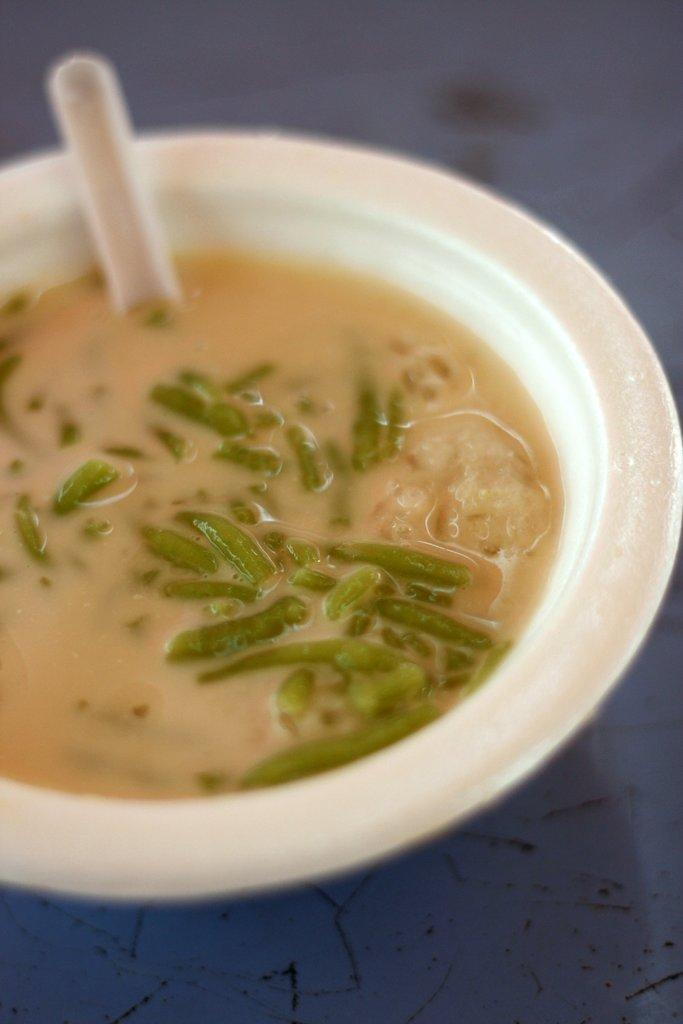What is in the bowl that is visible in the image? There is a bowl of soup in the image. Where is the bowl located in the image? The bowl is in the center of the image. What utensil is present in the bowl? There is a spoon in the bowl. What type of flag is being waved by the authority figure in the image? There is no flag or authority figure present in the image; it features a bowl of soup with a spoon in it. 